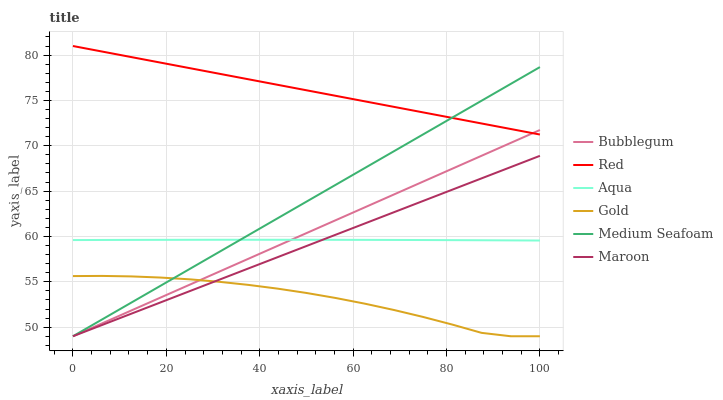Does Gold have the minimum area under the curve?
Answer yes or no. Yes. Does Red have the maximum area under the curve?
Answer yes or no. Yes. Does Aqua have the minimum area under the curve?
Answer yes or no. No. Does Aqua have the maximum area under the curve?
Answer yes or no. No. Is Bubblegum the smoothest?
Answer yes or no. Yes. Is Gold the roughest?
Answer yes or no. Yes. Is Aqua the smoothest?
Answer yes or no. No. Is Aqua the roughest?
Answer yes or no. No. Does Gold have the lowest value?
Answer yes or no. Yes. Does Aqua have the lowest value?
Answer yes or no. No. Does Red have the highest value?
Answer yes or no. Yes. Does Aqua have the highest value?
Answer yes or no. No. Is Maroon less than Red?
Answer yes or no. Yes. Is Red greater than Gold?
Answer yes or no. Yes. Does Red intersect Bubblegum?
Answer yes or no. Yes. Is Red less than Bubblegum?
Answer yes or no. No. Is Red greater than Bubblegum?
Answer yes or no. No. Does Maroon intersect Red?
Answer yes or no. No. 